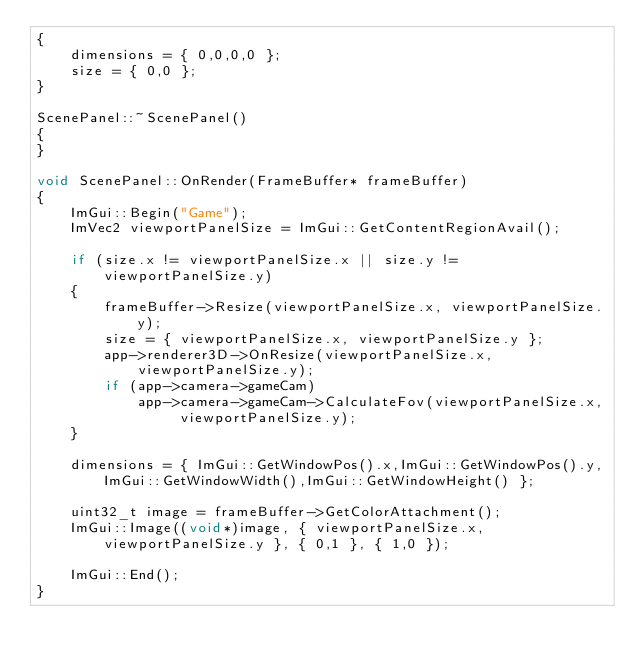<code> <loc_0><loc_0><loc_500><loc_500><_C++_>{
    dimensions = { 0,0,0,0 };
    size = { 0,0 };
}

ScenePanel::~ScenePanel()
{
}

void ScenePanel::OnRender(FrameBuffer* frameBuffer)
{
    ImGui::Begin("Game");
    ImVec2 viewportPanelSize = ImGui::GetContentRegionAvail();

    if (size.x != viewportPanelSize.x || size.y != viewportPanelSize.y)
    {
        frameBuffer->Resize(viewportPanelSize.x, viewportPanelSize.y);
        size = { viewportPanelSize.x, viewportPanelSize.y };
        app->renderer3D->OnResize(viewportPanelSize.x, viewportPanelSize.y);
        if (app->camera->gameCam)
            app->camera->gameCam->CalculateFov(viewportPanelSize.x, viewportPanelSize.y);
    }

    dimensions = { ImGui::GetWindowPos().x,ImGui::GetWindowPos().y,ImGui::GetWindowWidth(),ImGui::GetWindowHeight() };

    uint32_t image = frameBuffer->GetColorAttachment();
    ImGui::Image((void*)image, { viewportPanelSize.x, viewportPanelSize.y }, { 0,1 }, { 1,0 });

    ImGui::End();
}</code> 